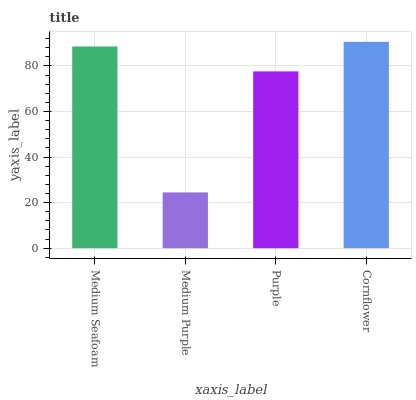Is Medium Purple the minimum?
Answer yes or no. Yes. Is Cornflower the maximum?
Answer yes or no. Yes. Is Purple the minimum?
Answer yes or no. No. Is Purple the maximum?
Answer yes or no. No. Is Purple greater than Medium Purple?
Answer yes or no. Yes. Is Medium Purple less than Purple?
Answer yes or no. Yes. Is Medium Purple greater than Purple?
Answer yes or no. No. Is Purple less than Medium Purple?
Answer yes or no. No. Is Medium Seafoam the high median?
Answer yes or no. Yes. Is Purple the low median?
Answer yes or no. Yes. Is Cornflower the high median?
Answer yes or no. No. Is Medium Seafoam the low median?
Answer yes or no. No. 